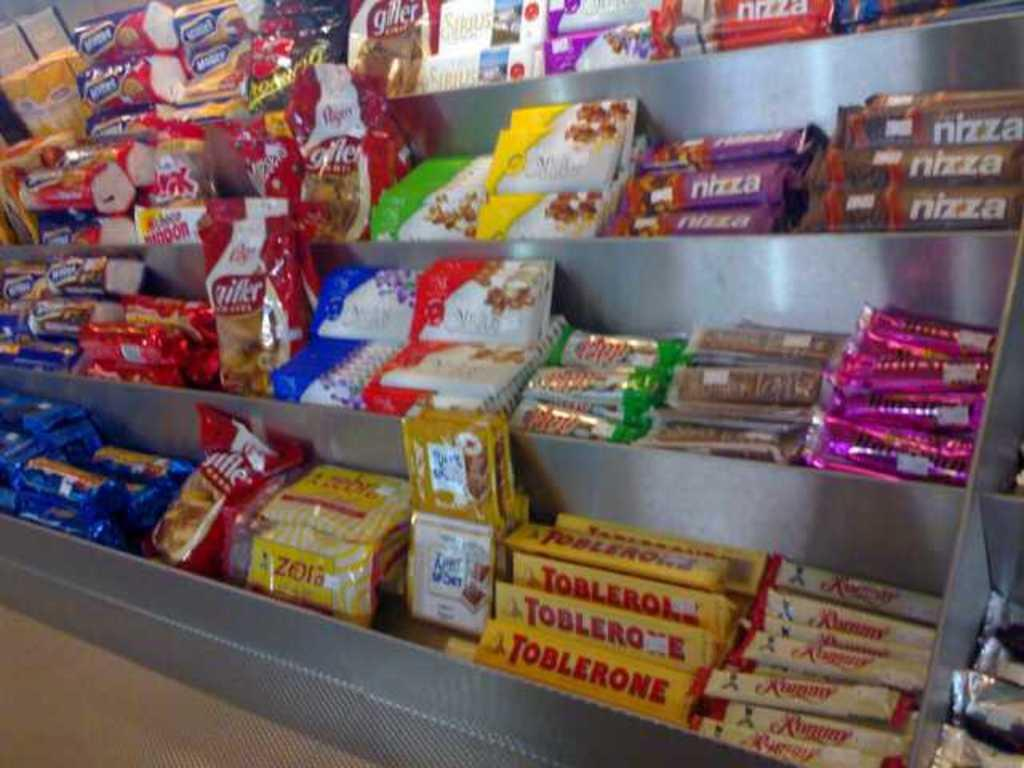Provide a one-sentence caption for the provided image. A candy display offers nizza and other goodies. 